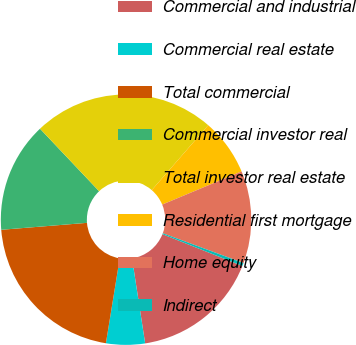<chart> <loc_0><loc_0><loc_500><loc_500><pie_chart><fcel>Commercial and industrial<fcel>Commercial real estate<fcel>Total commercial<fcel>Commercial investor real<fcel>Total investor real estate<fcel>Residential first mortgage<fcel>Home equity<fcel>Indirect<nl><fcel>16.53%<fcel>5.01%<fcel>21.14%<fcel>14.23%<fcel>23.45%<fcel>7.31%<fcel>11.92%<fcel>0.4%<nl></chart> 